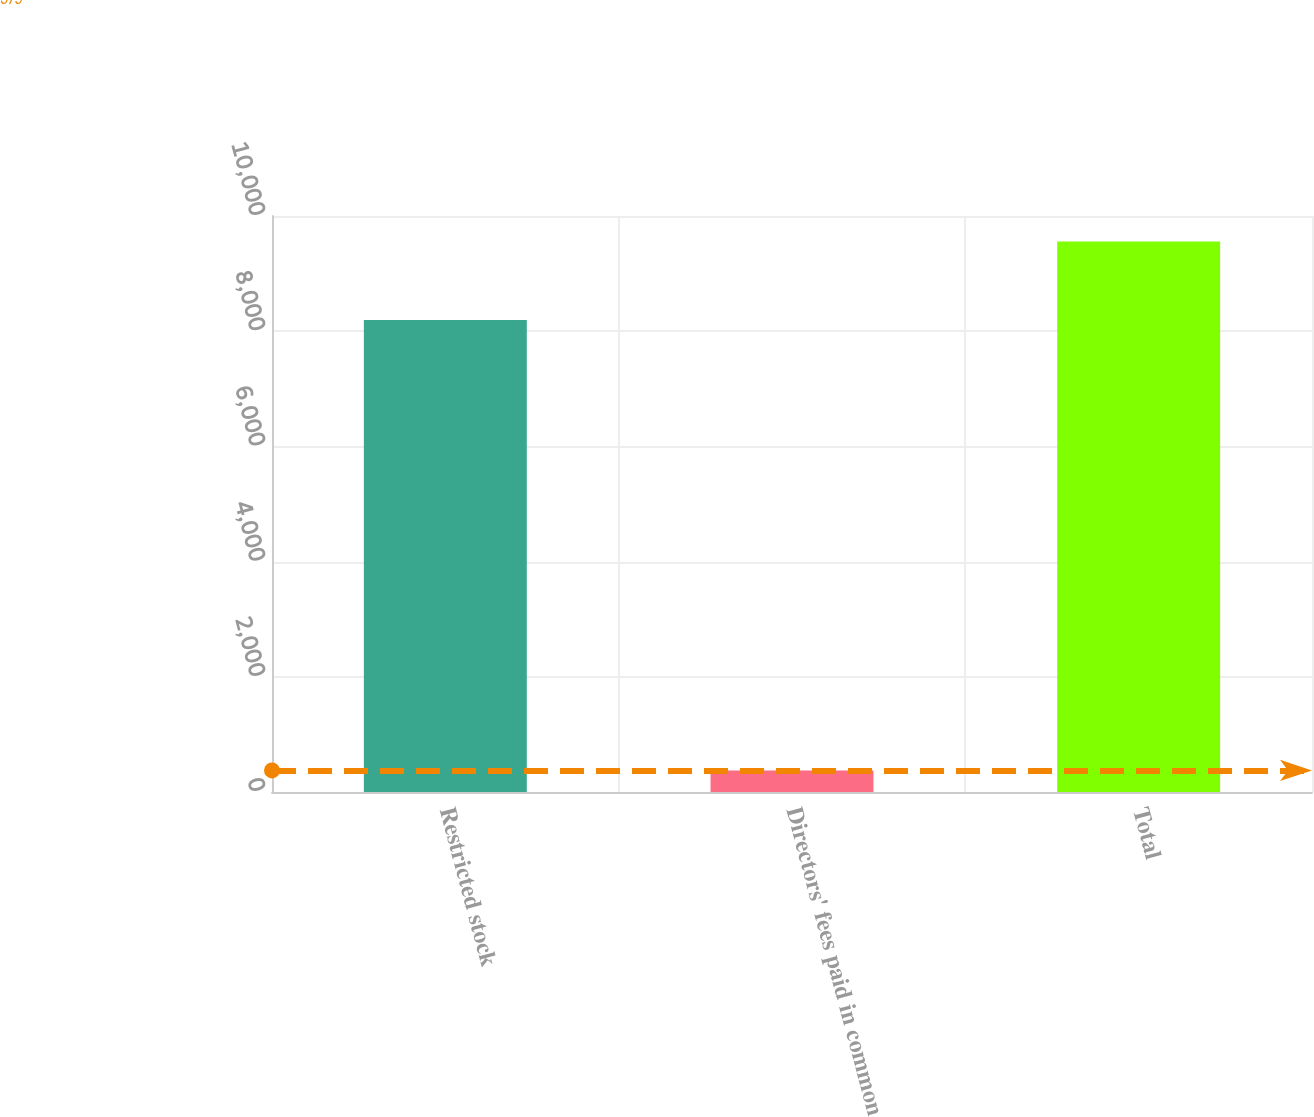Convert chart. <chart><loc_0><loc_0><loc_500><loc_500><bar_chart><fcel>Restricted stock<fcel>Directors' fees paid in common<fcel>Total<nl><fcel>8193<fcel>375<fcel>9556<nl></chart> 